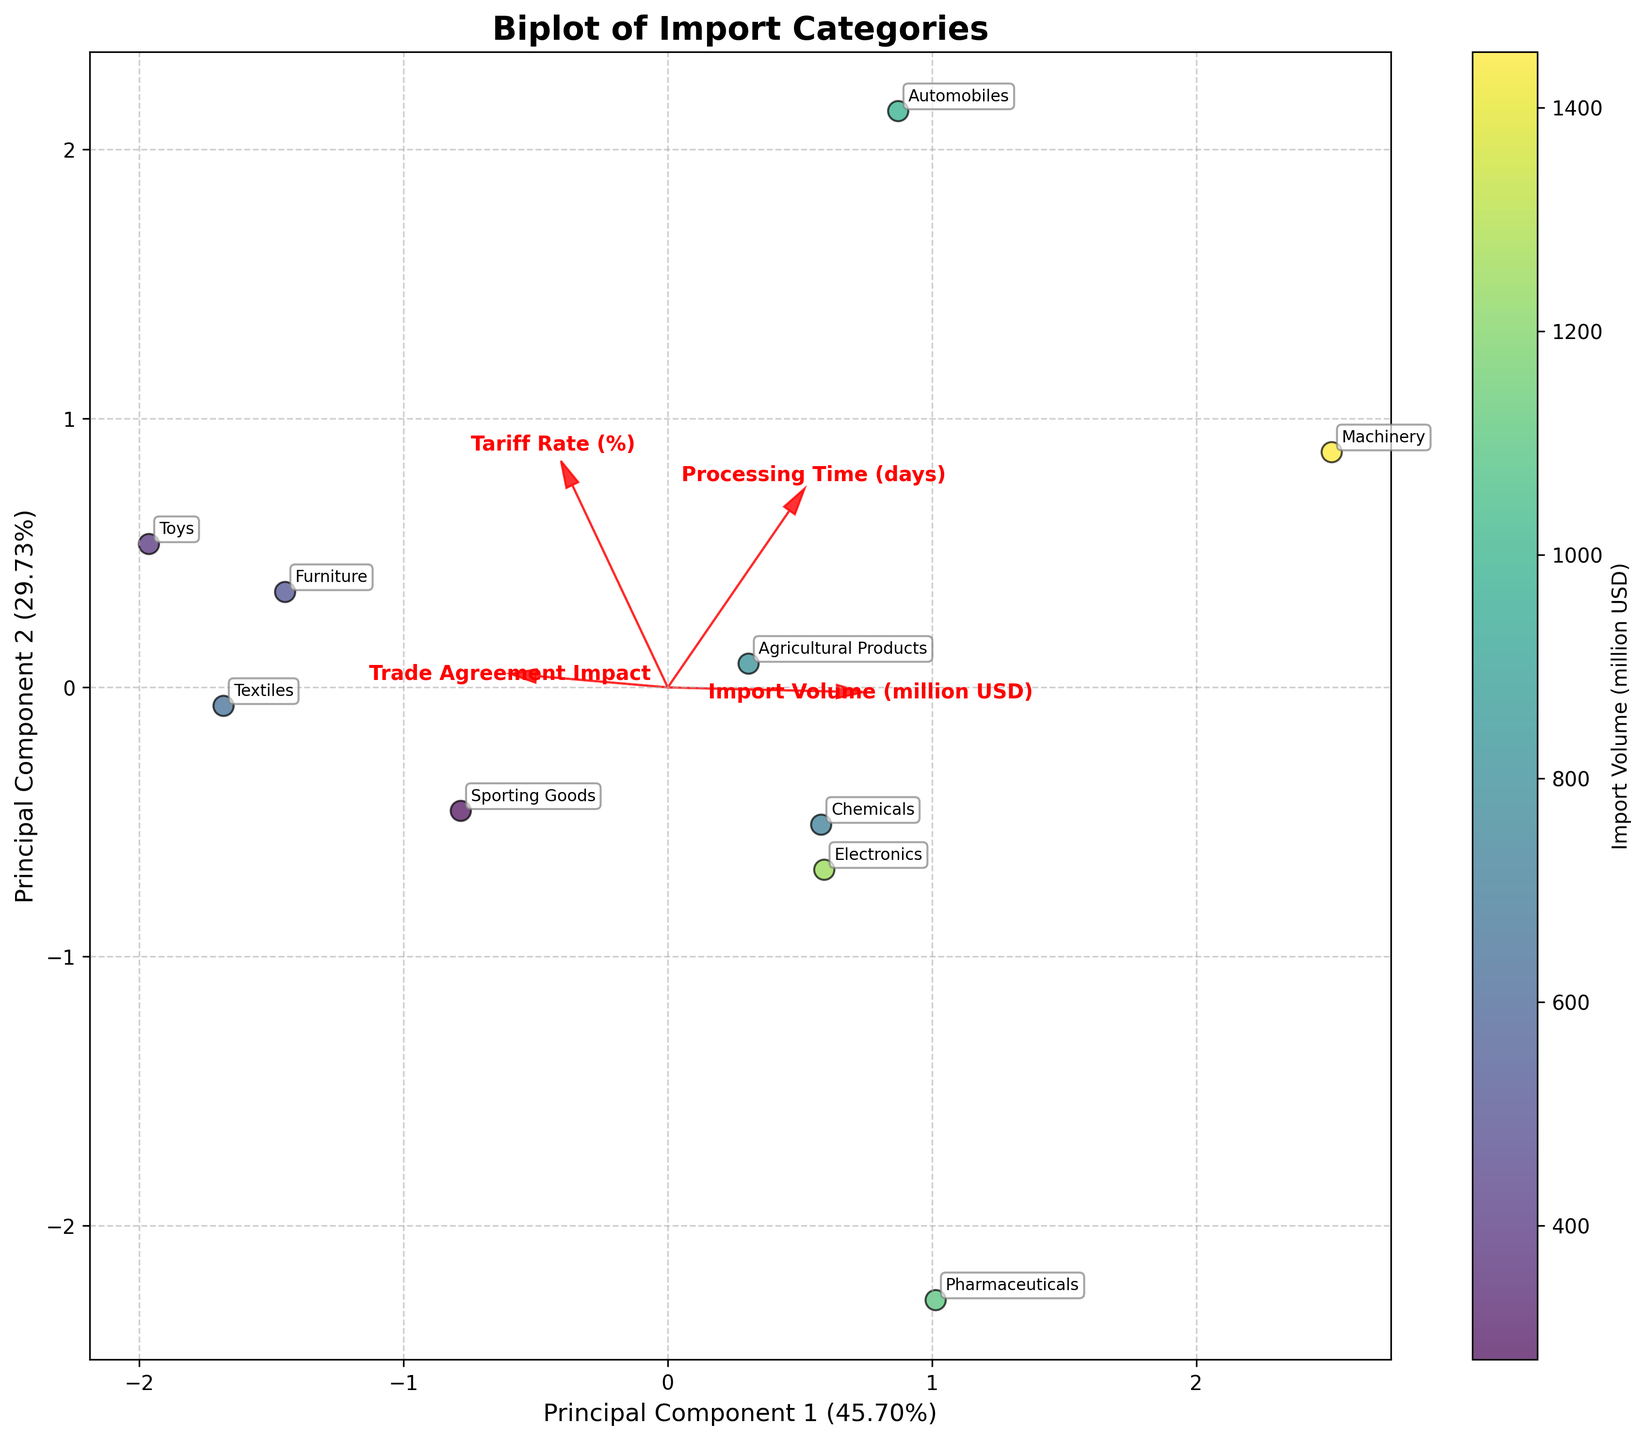What does the biplot's title indicate? The title of the biplot is usually found at the top and provides an overview of what the plot represents. In this case, it reads "Biplot of Import Categories", indicating that the plot visualizes various import categories and their attributes.
Answer: Biplot of Import Categories What do the x and y axes represent in the biplot? The x and y axes in the biplot represent the first and second principal components, respectively. The labels would inform us about the proportion of the total variance explained by each component, giving us insight into how much of the data's variability is captured by these two axes.
Answer: Principal Component 1 and Principal Component 2 Which category has the highest import volume, and where is it located on the biplot? The import volume is indicated by the color intensity, with a colorbar showing higher values in different colors. The data point with the darkest color, representing the highest import volume, is Machinery.
Answer: Machinery Which feature vector has the longest arrow in the biplot? In the biplot, the length of the arrows represents the magnitude of each feature's contribution to the principal components. The arrow for 'Import Volume (million USD)' seems to have the longest arrow among the features, indicating a strong contribution.
Answer: Import Volume (million USD) Which category qualifies as an outlier based on its positioning in the biplot? An outlier is a data point that is located far from the majority of other data points. According to the visual spread of data, the category "Toys" appears to be positioned further away from the rest, indicating it may be an outlier.
Answer: Toys How does the tariff rate vector align relative to the trade agreement impact vector? To determine the alignment, we observe the direction of the vectors. The 'Tariff Rate (%)' vector and the 'Trade Agreement Impact' vector point in slightly different directions, indicating that these two features are not perfectly correlated and have some distinct effects on the principal components.
Answer: Slightly different directions What relationships can be deduced between import volume and processing time from the biplot? By examining the direction and length of the vectors for 'Import Volume (million USD)' and 'Processing Time (days)', one can deduce the correlation. The vectors are not aligned in parallel, suggesting that there is no strong linear relationship between these two features. The angles indicate they might be weakly or moderately related.
Answer: Weak to moderate correlation Which categories have relatively low processing times according to the biplot? Categories with low processing times would be closer to the negative end of the 'Processing Time (days)' vector. Observing these data points, Pharmaceuticals and Sporting Goods appear to have relatively low processing times.
Answer: Pharmaceuticals and Sporting Goods 